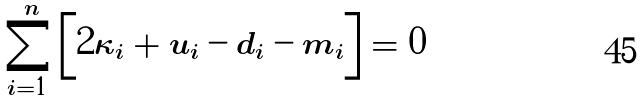Convert formula to latex. <formula><loc_0><loc_0><loc_500><loc_500>\sum _ { i = 1 } ^ { n } \left [ 2 \kappa _ { i } + u _ { i } - d _ { i } - m _ { i } \right ] = 0</formula> 